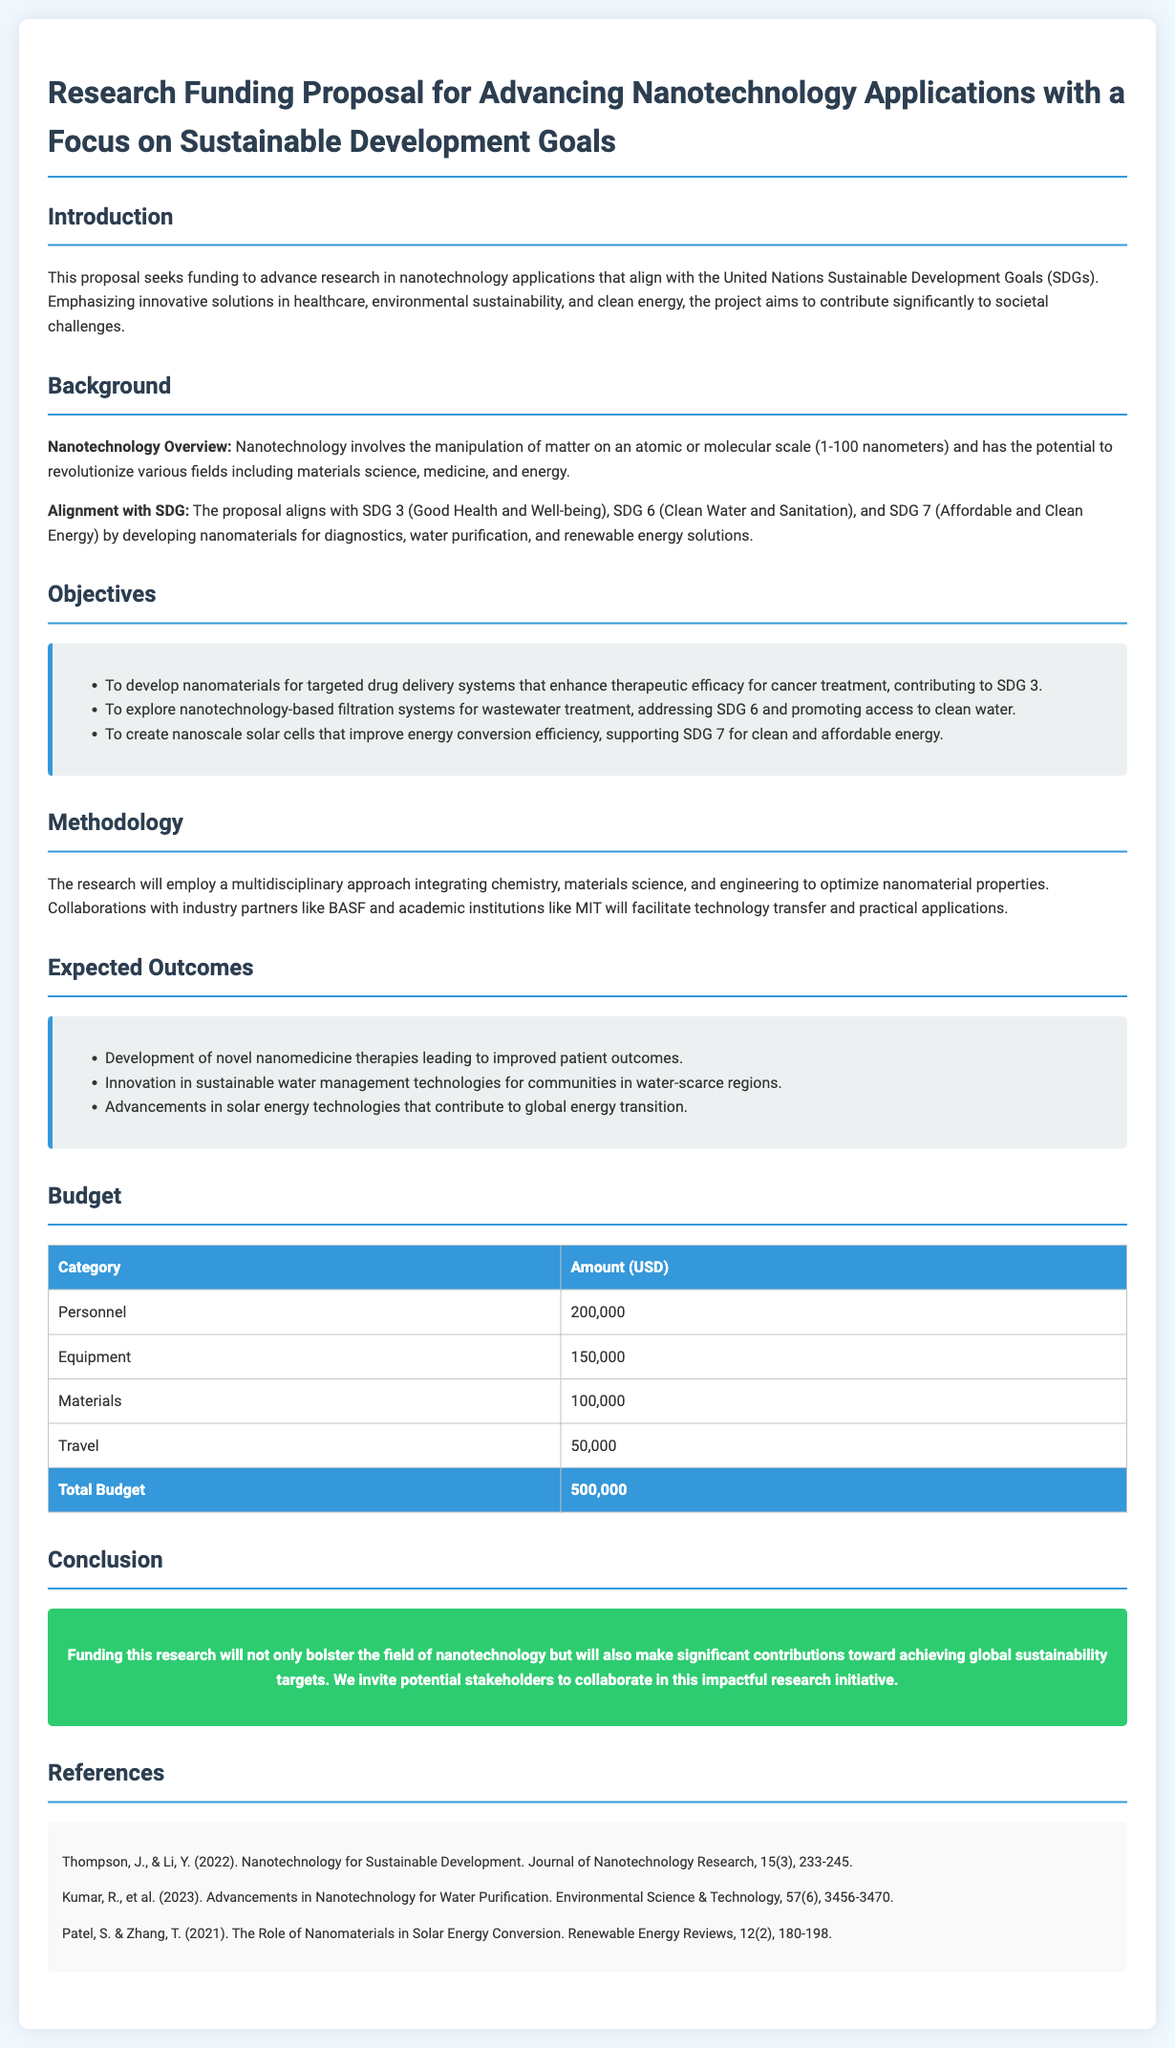What is the total budget? The total budget is outlined in the budget section of the document, which sums up all the individual expenses.
Answer: 500,000 What is the main focus of the research proposal? The introduction highlights that the main focus is advancing nanotechnology applications aligned with the Sustainable Development Goals.
Answer: Sustainable Development Goals Which SDG is related to clean water? The background section indicates that SDG 6 pertains to clean water and sanitation.
Answer: SDG 6 What kind of approach will the research employ? The methodology section specifies that a multidisciplinary approach will be taken in the research.
Answer: Multidisciplinary approach Who are some industry partners mentioned in the proposal? The methodology section cites collaborations with industry partners like BASF, which indicates the importance of partnerships for technology transfer.
Answer: BASF What is one expected outcome of the research? The expected outcomes section lists multiple expected results, one being the development of novel nanomedicine therapies.
Answer: Improved patient outcomes What type of nanotechnology application does the proposal propose for energy conversion? The objectives section mentions creating nanoscale solar cells aimed at improving energy conversion efficiency.
Answer: Nanoscale solar cells What is the budget allocated for personnel? The budget specifies an amount assigned under the personnel category for funding purposes.
Answer: 200,000 Which journal published a reference on nanotechnology for sustainable development? The references section lists materials that provide foundational knowledge, one being published in the Journal of Nanotechnology Research.
Answer: Journal of Nanotechnology Research 